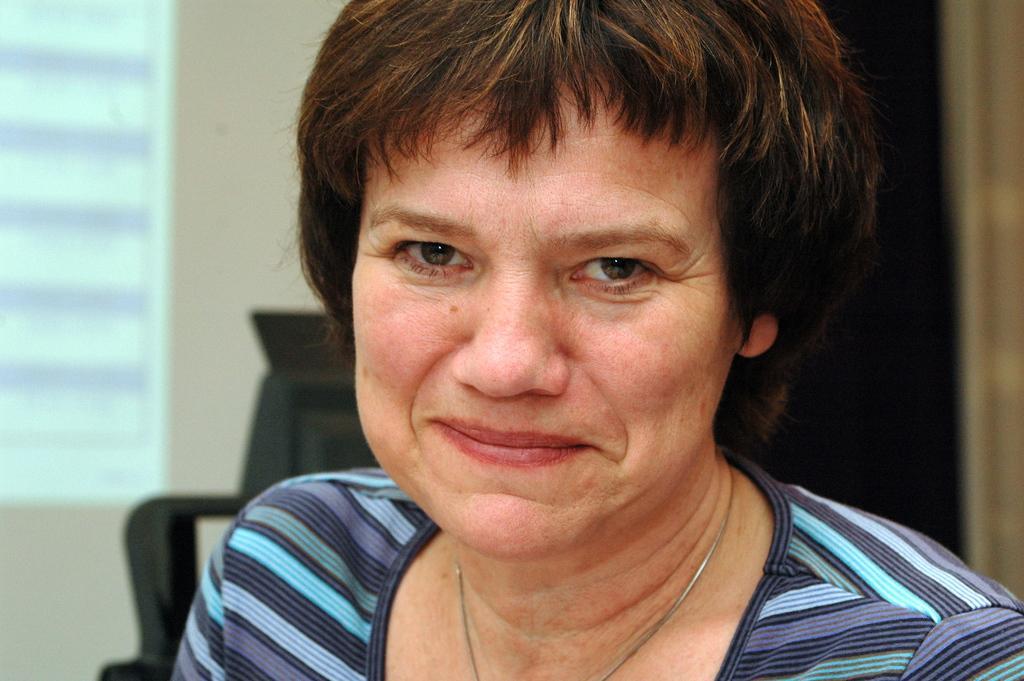Could you give a brief overview of what you see in this image? In this image we can see a woman. In the background there is an object, wall and a window. 